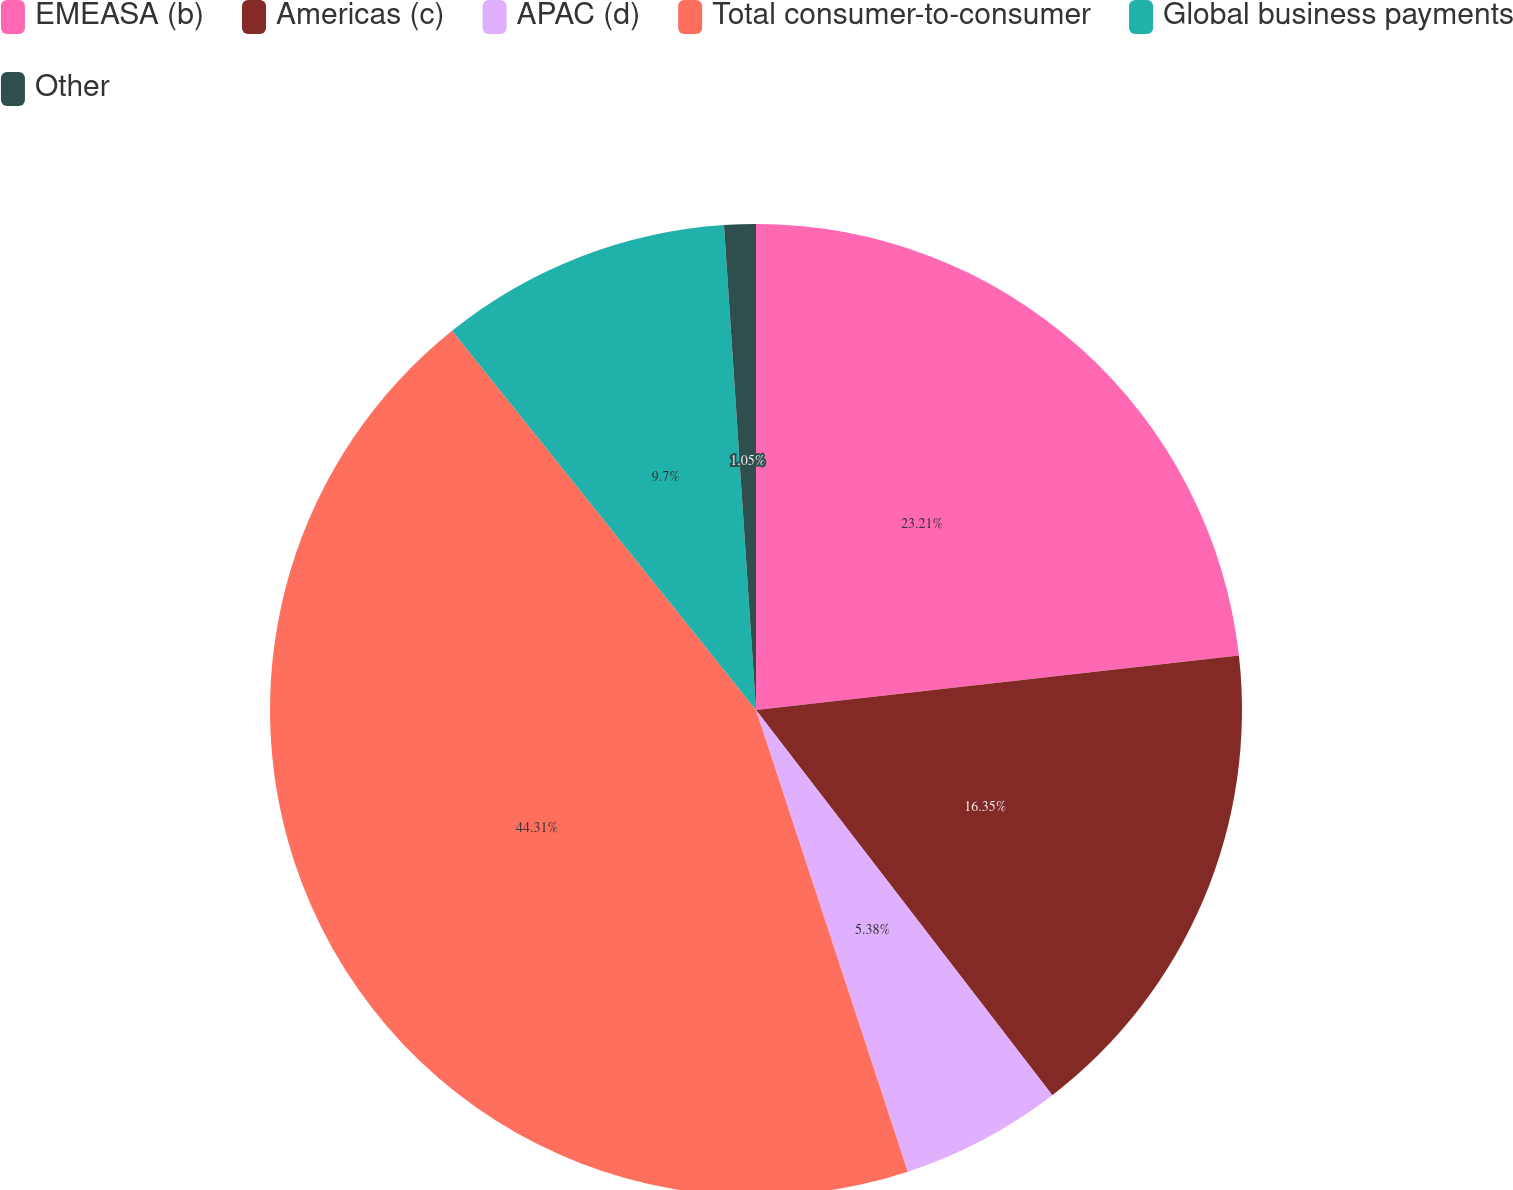<chart> <loc_0><loc_0><loc_500><loc_500><pie_chart><fcel>EMEASA (b)<fcel>Americas (c)<fcel>APAC (d)<fcel>Total consumer-to-consumer<fcel>Global business payments<fcel>Other<nl><fcel>23.21%<fcel>16.35%<fcel>5.38%<fcel>44.3%<fcel>9.7%<fcel>1.05%<nl></chart> 